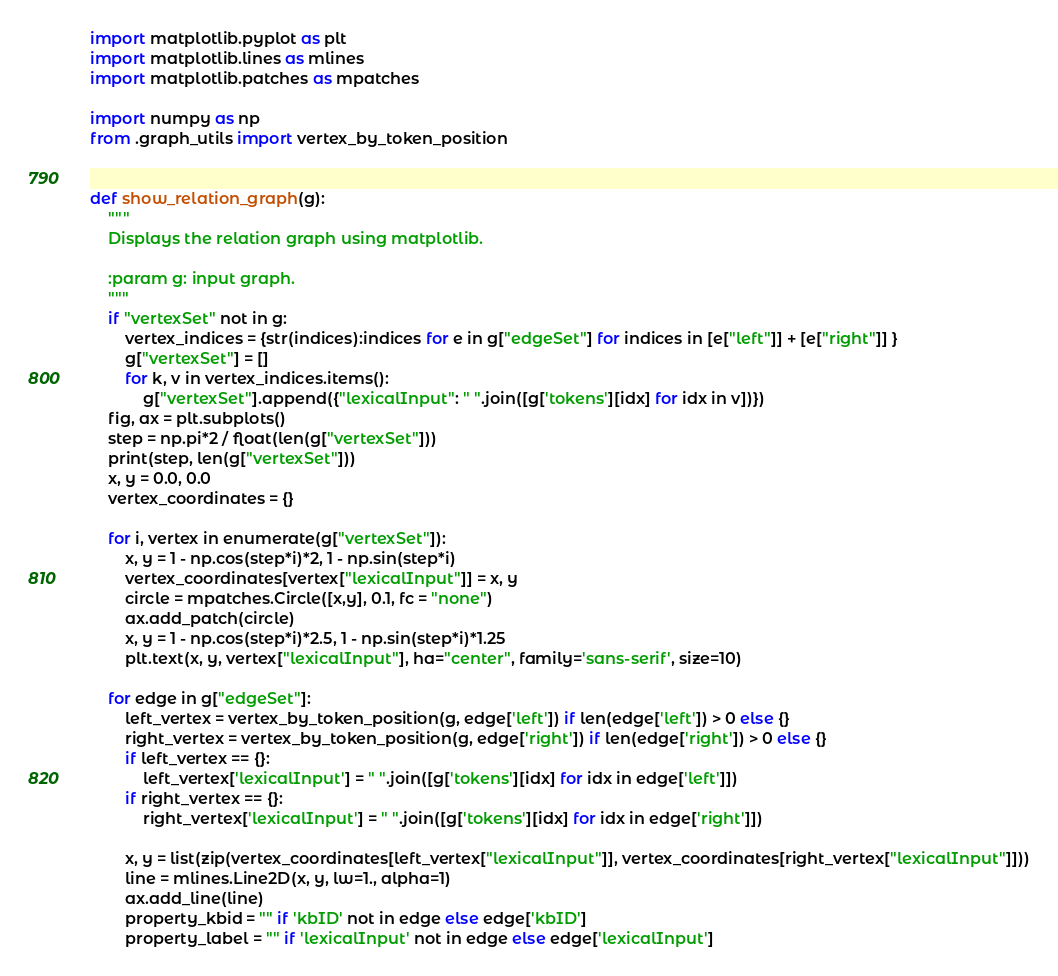Convert code to text. <code><loc_0><loc_0><loc_500><loc_500><_Python_>import matplotlib.pyplot as plt
import matplotlib.lines as mlines
import matplotlib.patches as mpatches

import numpy as np
from .graph_utils import vertex_by_token_position


def show_relation_graph(g):
    """
    Displays the relation graph using matplotlib.

    :param g: input graph.
    """
    if "vertexSet" not in g:
        vertex_indices = {str(indices):indices for e in g["edgeSet"] for indices in [e["left"]] + [e["right"]] }
        g["vertexSet"] = []
        for k, v in vertex_indices.items():
            g["vertexSet"].append({"lexicalInput": " ".join([g['tokens'][idx] for idx in v])})
    fig, ax = plt.subplots()
    step = np.pi*2 / float(len(g["vertexSet"]))
    print(step, len(g["vertexSet"]))
    x, y = 0.0, 0.0
    vertex_coordinates = {}

    for i, vertex in enumerate(g["vertexSet"]):
        x, y = 1 - np.cos(step*i)*2, 1 - np.sin(step*i)
        vertex_coordinates[vertex["lexicalInput"]] = x, y
        circle = mpatches.Circle([x,y], 0.1, fc = "none")
        ax.add_patch(circle)
        x, y = 1 - np.cos(step*i)*2.5, 1 - np.sin(step*i)*1.25
        plt.text(x, y, vertex["lexicalInput"], ha="center", family='sans-serif', size=10)

    for edge in g["edgeSet"]:
        left_vertex = vertex_by_token_position(g, edge['left']) if len(edge['left']) > 0 else {}
        right_vertex = vertex_by_token_position(g, edge['right']) if len(edge['right']) > 0 else {}
        if left_vertex == {}:
            left_vertex['lexicalInput'] = " ".join([g['tokens'][idx] for idx in edge['left']])
        if right_vertex == {}:
            right_vertex['lexicalInput'] = " ".join([g['tokens'][idx] for idx in edge['right']])

        x, y = list(zip(vertex_coordinates[left_vertex["lexicalInput"]], vertex_coordinates[right_vertex["lexicalInput"]]))
        line = mlines.Line2D(x, y, lw=1., alpha=1)
        ax.add_line(line)
        property_kbid = "" if 'kbID' not in edge else edge['kbID']
        property_label = "" if 'lexicalInput' not in edge else edge['lexicalInput']</code> 